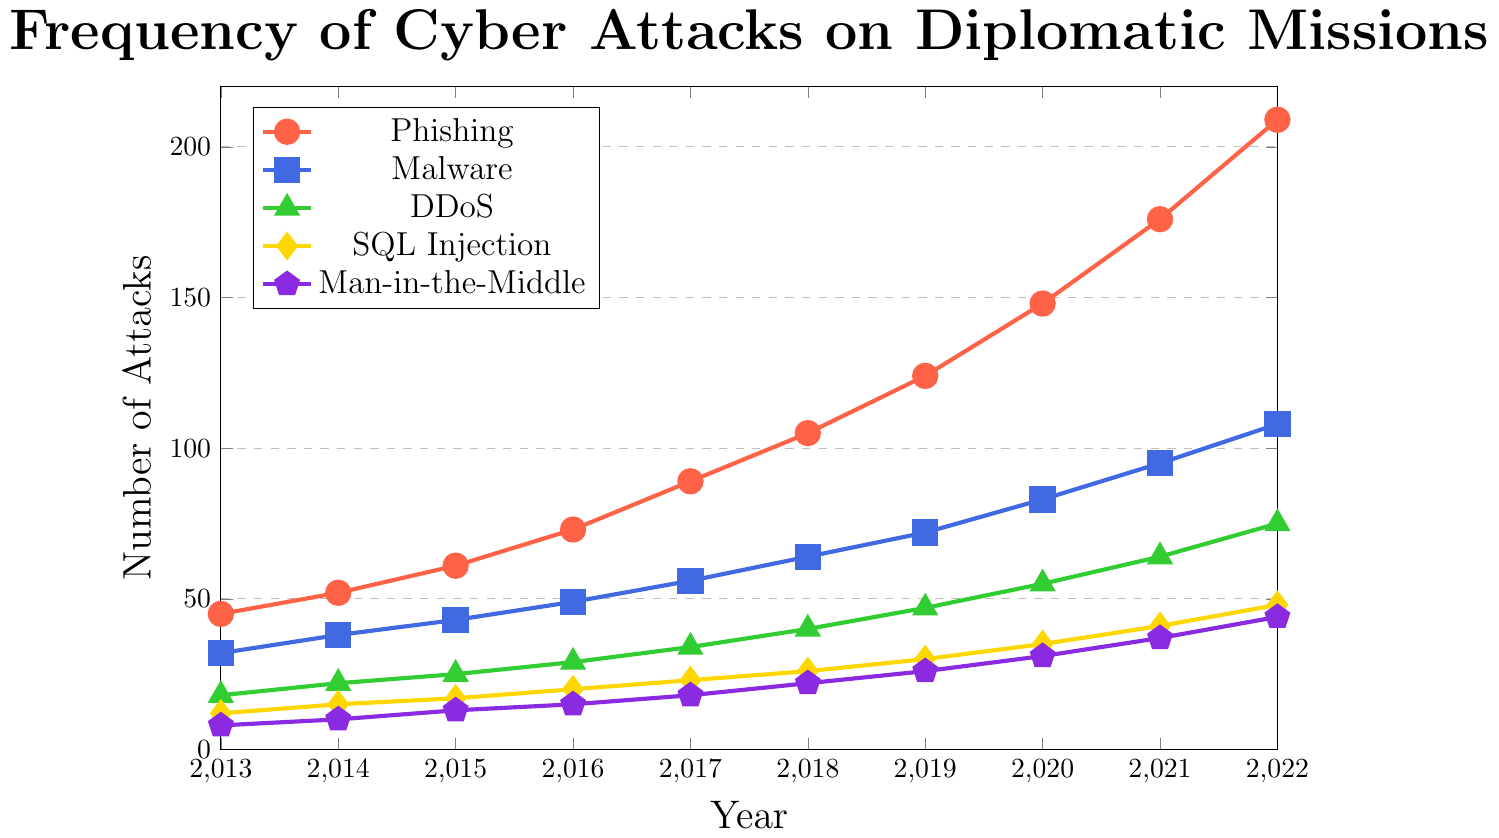What year saw the highest number of Phishing attacks? To determine the year with the highest number of Phishing attacks, look for the peak in the red line on the graph. The highest point occurs in 2022 with 209 attacks.
Answer: 2022 Which type of attack had the largest increase from 2013 to 2022? Calculate the difference in the number of attacks for each type from 2013 to 2022, and identify the largest increase. Phishing increased by 209 - 45 = 164, Malware by 108 - 32 = 76, DDoS by 75 - 18 = 57, SQL Injection by 48 - 12 = 36, and Man-in-the-Middle by 44 - 8 = 36. Phishing had the highest increase.
Answer: Phishing Are SQL Injection attacks more frequent in 2022 than DDoS attacks were in 2017? Compare the number of SQL Injection attacks in 2022 (48) with the number of DDoS attacks in 2017 (34). 48 is greater than 34, so yes.
Answer: Yes Between 2013 and 2022, which year saw the largest increase in Malware attacks compared to the previous year? Calculate the yearly increase in Malware attacks by subtracting the attacks in the previous year from the current year. The years and increments are: 2014 (6), 2015 (5), 2016 (6), 2017 (7), 2018 (8), 2019 (8), 2020 (11), 2021 (12), 2022 (13). The largest increase was between 2021 and 2022 with an increase of 13.
Answer: 2022 In which year did Man-in-the-Middle attacks surpass 20? Review the purple line for Man-in-the-Middle attacks, identifying the first year where the count exceeds 20. This happens in 2018 with 22 attacks.
Answer: 2018 What is the sum of all Phishing and Malware attacks in 2020? Sum the number of Phishing attacks in 2020 (148) and Malware attacks in 2020 (83): 148 + 83 = 231.
Answer: 231 Which attack type consistently had the least number of attacks each year? Compare the counts of all attack types each year. Man-in-the-Middle attacks (purple line) consistently have the lowest number each year.
Answer: Man-in-the-Middle By how much did the number of DDoS attacks increase from 2016 to 2019? Subtract the number of DDoS attacks in 2016 (29) from the number in 2019 (47): 47 - 29 = 18.
Answer: 18 Which two types of attacks had the closest number of incidents in 2015? Compare the number of attacks in 2015: Phishing (61), Malware (43), DDoS (25), SQL Injection (17), and Man-in-the-Middle (13). SQL Injection and Man-in-the-Middle, with counts of 17 and 13 respectively, are the closest.
Answer: SQL Injection and Man-in-the-Middle How many total attacks were there for all types in 2018? Sum the number of attacks for each type in 2018: Phishing (105), Malware (64), DDoS (40), SQL Injection (26), Man-in-the-Middle (22). Total: 105 + 64 + 40 + 26 + 22 = 257.
Answer: 257 